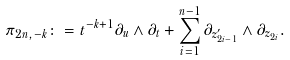<formula> <loc_0><loc_0><loc_500><loc_500>\pi _ { 2 n , - k } \colon = t ^ { - k + 1 } \partial _ { u } \wedge \partial _ { t } + \sum _ { i = 1 } ^ { n - 1 } \partial _ { z _ { 2 i - 1 } ^ { \prime } } \wedge \partial _ { z _ { 2 i } } .</formula> 